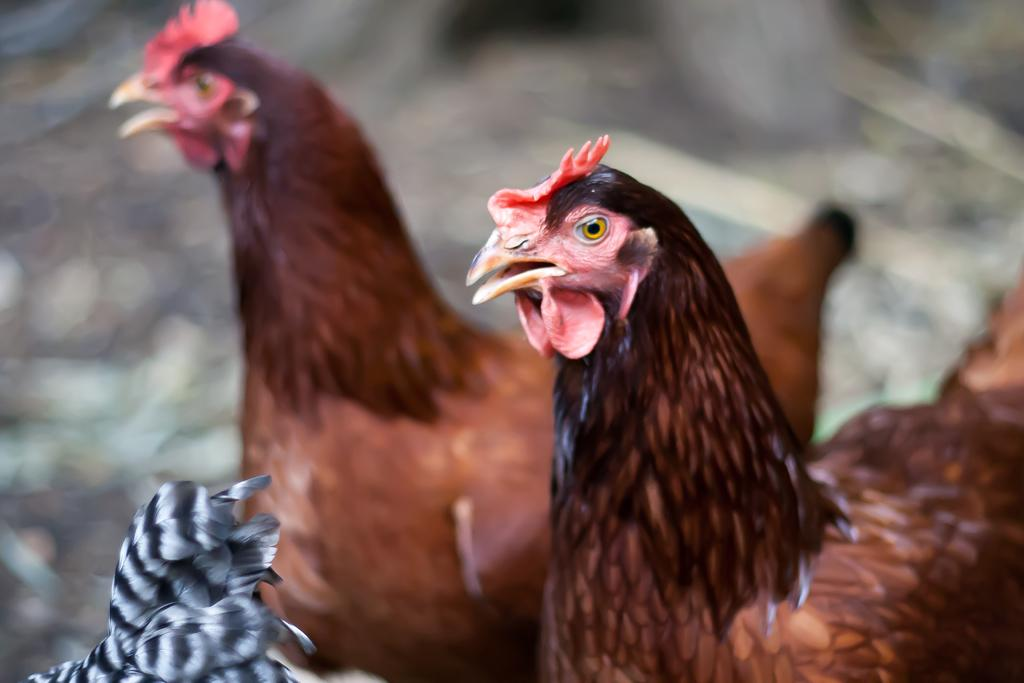What animals are in the foreground of the image? There are two hens in the foreground of the image. Can you describe the background of the image? The background of the image is blurry. What can be seen at the bottom of the image? There are feathers at the bottom of the image. How many goldfish are swimming in the image? There are no goldfish present in the image. What type of plate is being used by the hens in the image? There is no plate visible in the image; it only features two hens and feathers at the bottom. 